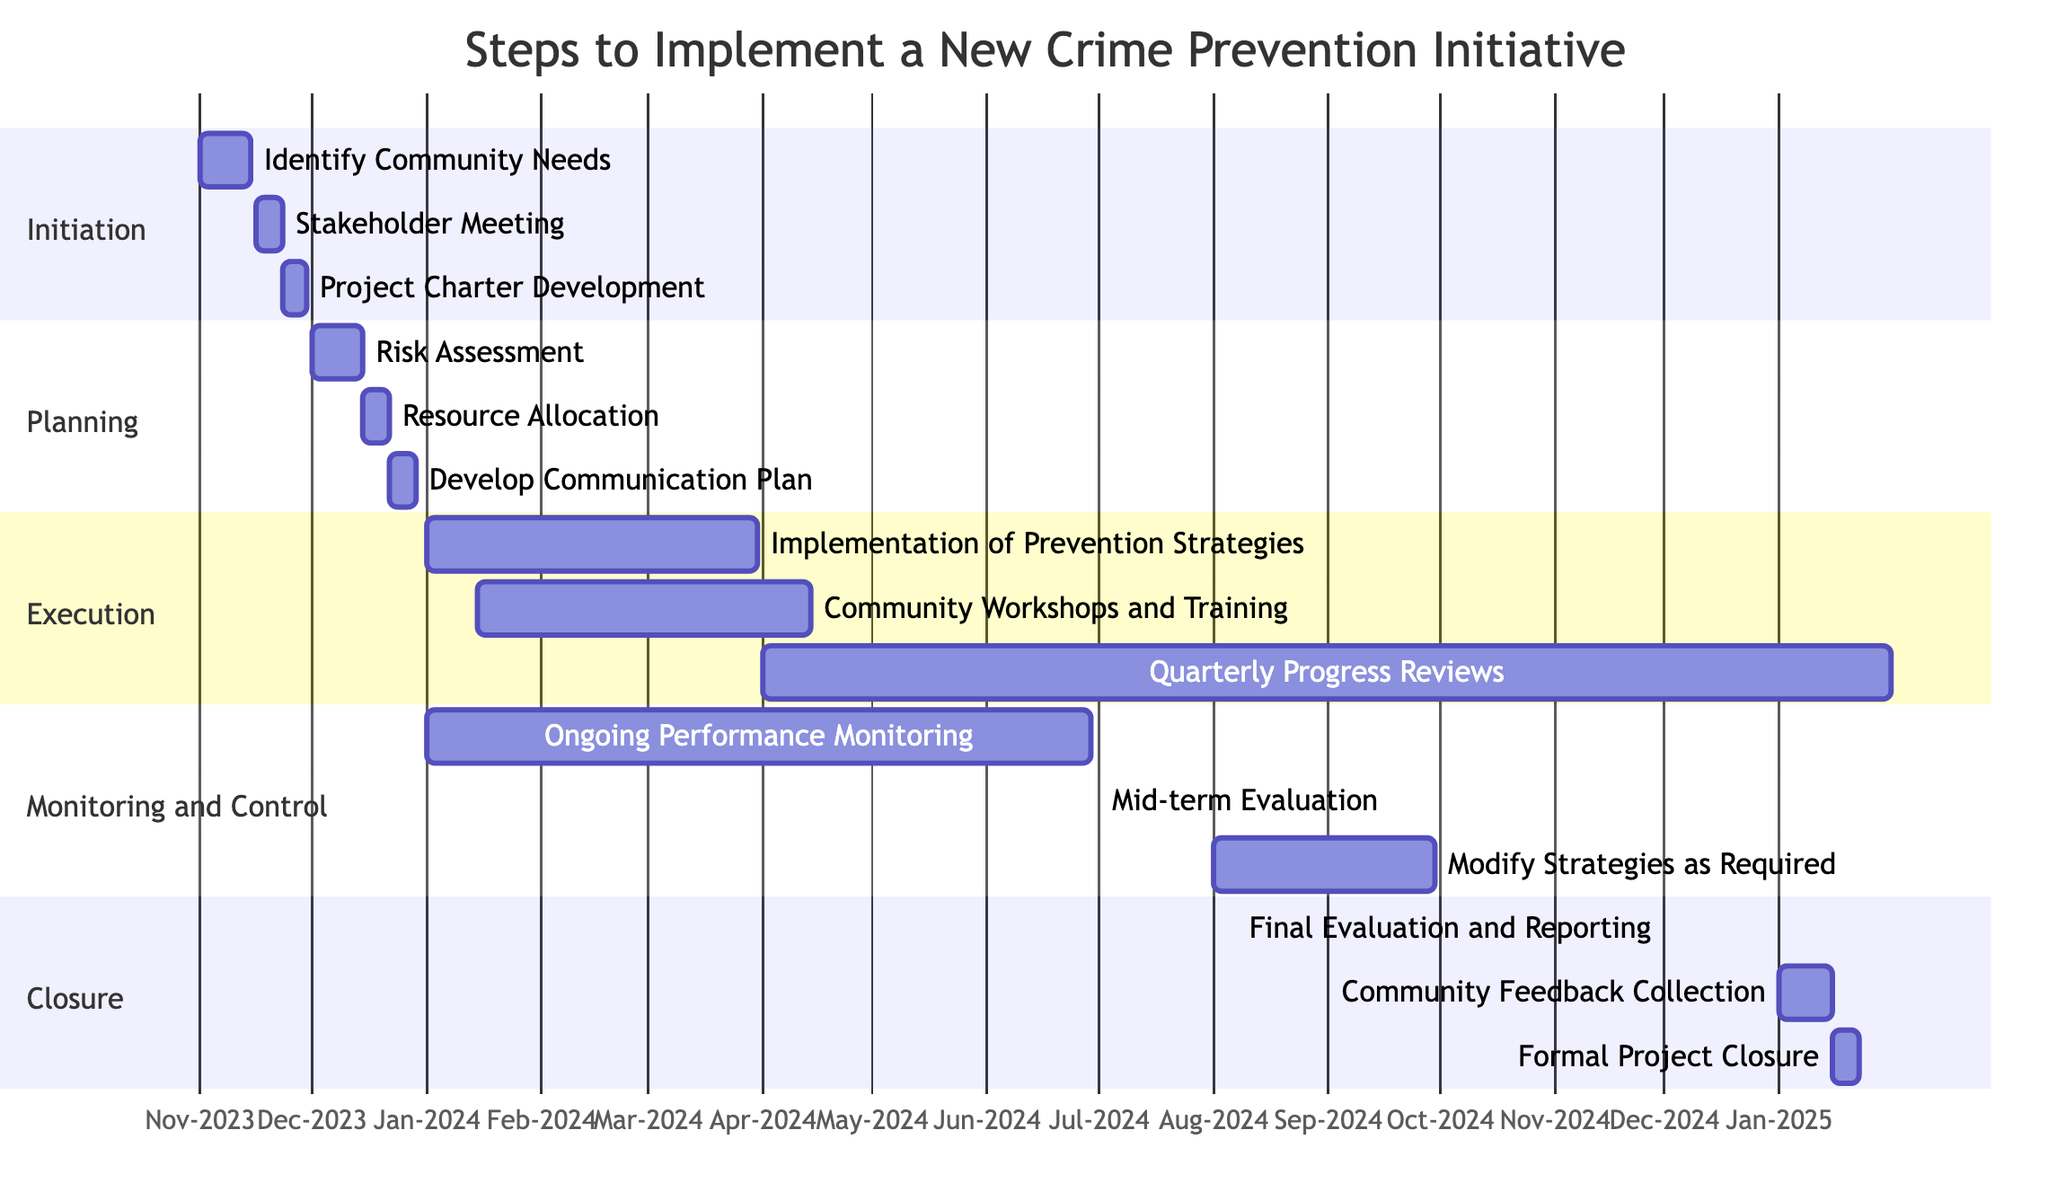What is the duration of the "Identify Community Needs" task? The "Identify Community Needs" task has a duration of "2 weeks" as specified in the diagram under the Initiation phase.
Answer: 2 weeks What is the task that immediately follows the "Stakeholder Meeting"? The task that follows "Stakeholder Meeting" is "Project Charter Development", which starts on November 23, 2023.
Answer: Project Charter Development How many tasks are involved in the Planning phase? The Planning phase consists of three tasks: "Risk Assessment," "Resource Allocation," and "Develop Communication Plan." Therefore, the number of tasks is three.
Answer: 3 When does the "Final Evaluation and Reporting" task begin? The "Final Evaluation and Reporting" task begins on December 1, 2024, as indicated in the Closure section.
Answer: December 1, 2024 Which task has the longest duration in the Execution phase? The task with the longest duration in the Execution phase is "Implementation of Prevention Strategies," lasting for 3 months (or 90 days).
Answer: Implementation of Prevention Strategies Which task overlaps with the "Community Workshops and Training"? The "Implementation of Prevention Strategies" task overlaps with "Community Workshops and Training" as both start in January 2024, with the former starting on January 1 and the latter on January 15.
Answer: Implementation of Prevention Strategies What is the total duration of the Monitoring and Control phase? The total duration of the Monitoring and Control phase includes "Ongoing Performance Monitoring" (6 months), "Mid-term Evaluation" (1 month), and "Modify Strategies as Required" (2 months). Therefore, the total duration is 9 months.
Answer: 9 months Which task follows the "Community Feedback Collection"? The task that follows "Community Feedback Collection" is "Formal Project Closure", which starts on January 15, 2025.
Answer: Formal Project Closure What is the start date of the "Mid-term Evaluation"? The "Mid-term Evaluation" starts on July 1, 2024, according to the schedule in the Monitoring and Control phase.
Answer: July 1, 2024 